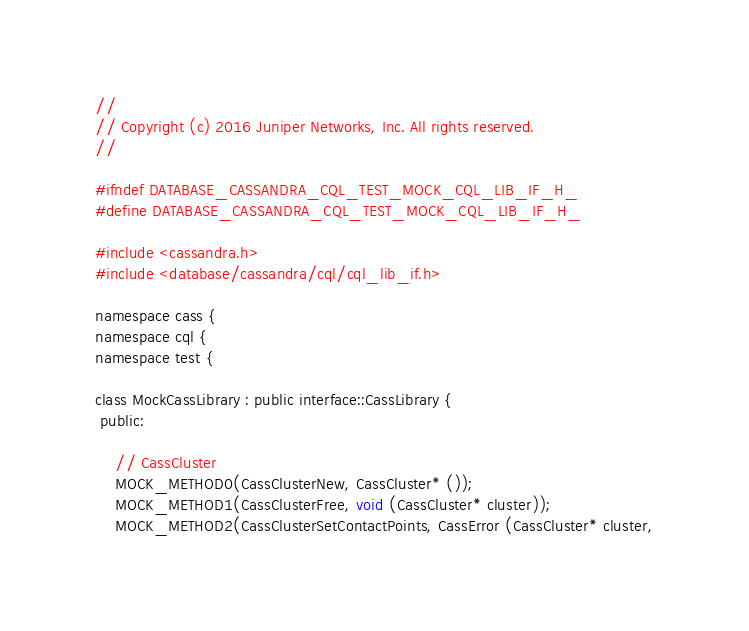Convert code to text. <code><loc_0><loc_0><loc_500><loc_500><_C_>//
// Copyright (c) 2016 Juniper Networks, Inc. All rights reserved.
//

#ifndef DATABASE_CASSANDRA_CQL_TEST_MOCK_CQL_LIB_IF_H_
#define DATABASE_CASSANDRA_CQL_TEST_MOCK_CQL_LIB_IF_H_

#include <cassandra.h>
#include <database/cassandra/cql/cql_lib_if.h>

namespace cass {
namespace cql {
namespace test {

class MockCassLibrary : public interface::CassLibrary {
 public:

    // CassCluster
    MOCK_METHOD0(CassClusterNew, CassCluster* ());
    MOCK_METHOD1(CassClusterFree, void (CassCluster* cluster));
    MOCK_METHOD2(CassClusterSetContactPoints, CassError (CassCluster* cluster,</code> 